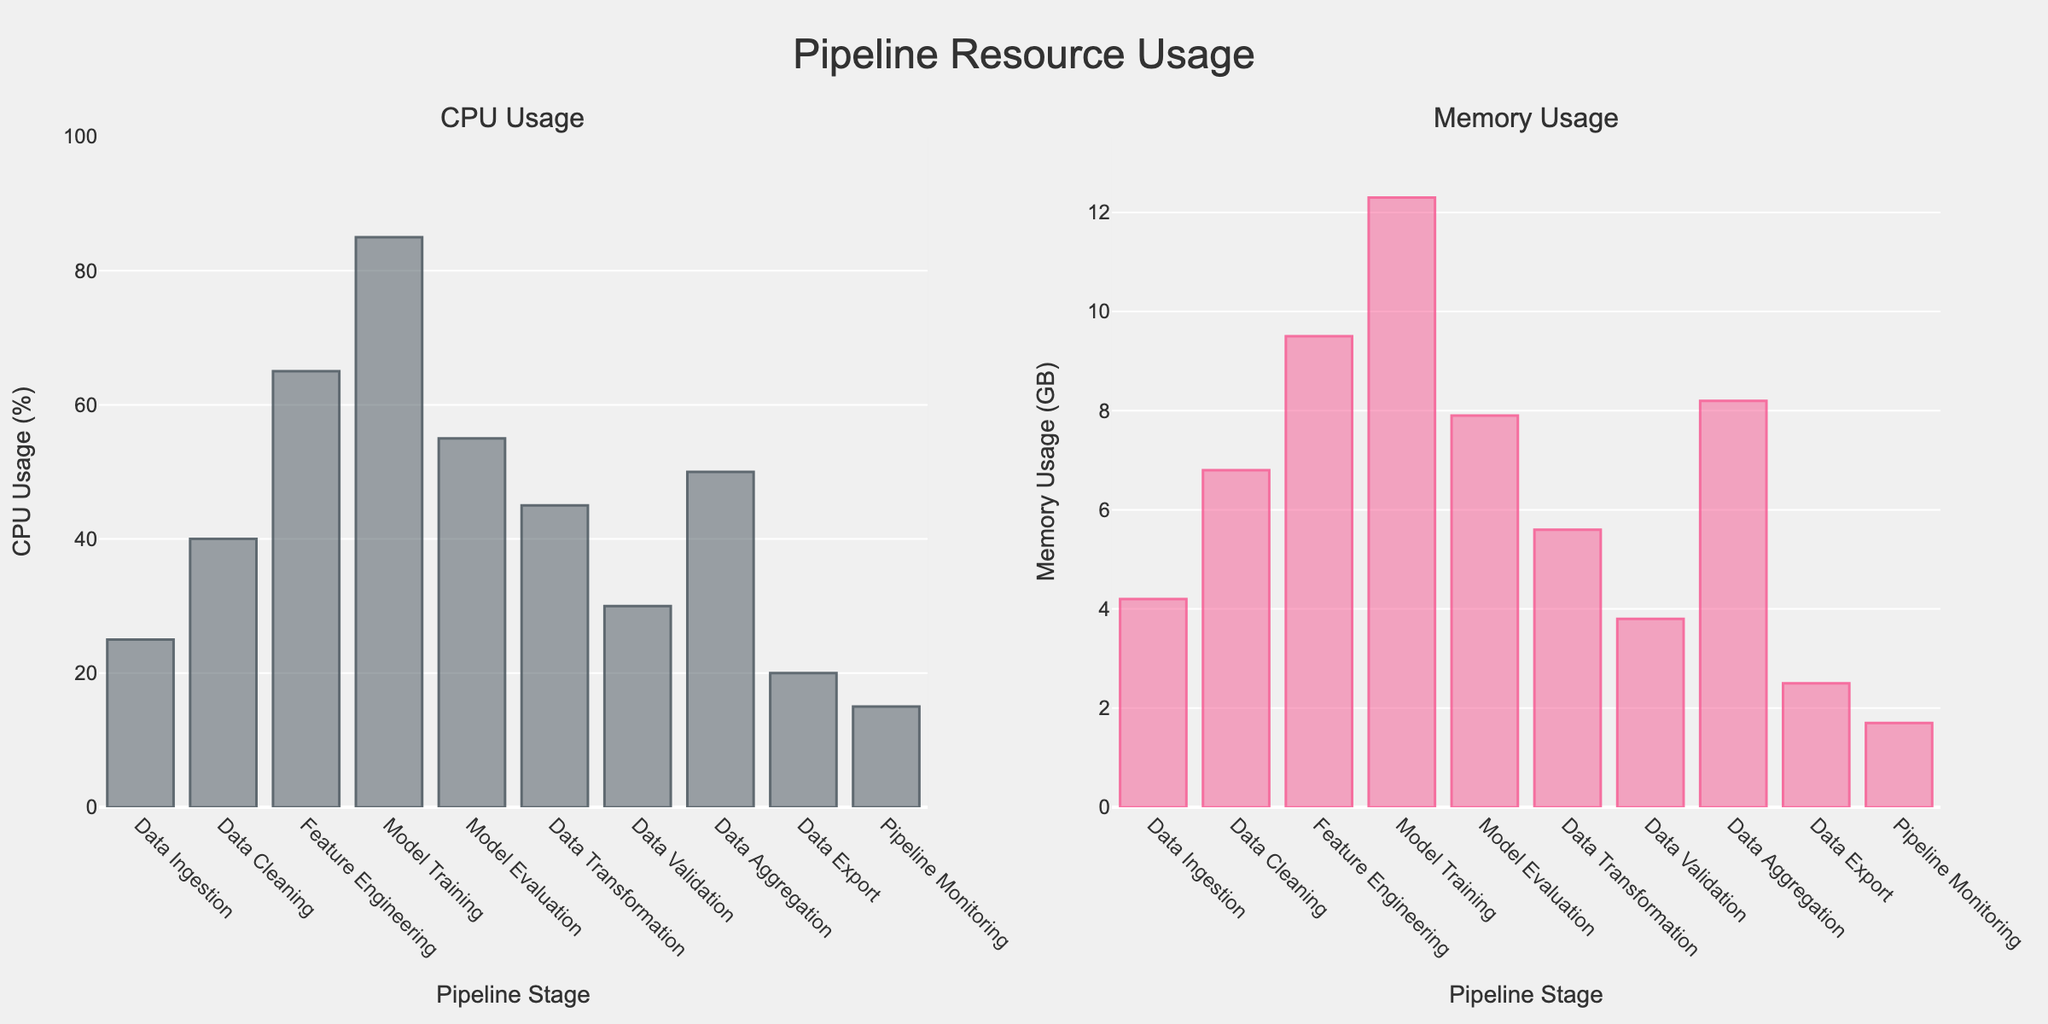What is the title of the figure? The title of the figure is located at the top center of the plot and reads "Pipeline Resource Usage."
Answer: Pipeline Resource Usage What is the CPU usage percentage during Model Training? Locate the bar corresponding to the "Model Training" stage on the left subplot titled "CPU Usage." The height of this bar represents the CPU usage, which is 85%.
Answer: 85% How much memory is used during the Data Aggregation stage? Find the bar labeled "Data Aggregation" in the right subplot titled "Memory Usage." The height of this bar shows the memory usage, which is 8.2 GB.
Answer: 8.2 GB During which stage is the lowest CPU usage observed? Look at the left subplot (CPU Usage) and find the bar with the shortest height. The stage with the shortest bar is "Pipeline Monitoring," indicating the lowest CPU usage.
Answer: Pipeline Monitoring Which stage has the highest memory usage? Check the right subplot (Memory Usage) and identify the bar with the greatest height. The "Model Training" stage has the highest bar, representing the highest memory usage.
Answer: Model Training What is the combined CPU usage percentage for Data Ingestion and Data Export? Identify the CPU usage for "Data Ingestion" (25%) and "Data Export" (20%). Sum these values: 25% + 20% = 45%.
Answer: 45% How does the CPU usage of Data Cleaning compare to Data Validation? Locate the CPU usage for "Data Cleaning" (40%) and "Data Validation" (30%). Data Cleaning has 10% more CPU usage than Data Validation.
Answer: Data Cleaning has 10% more CPU usage than Data Validation What stages have a memory usage greater than 8 GB? Check the right subplot (Memory Usage) and find the bars where the height exceeds 8 GB. These stages are "Feature Engineering" (9.5 GB), "Model Training" (12.3 GB), and "Data Aggregation" (8.2 GB).
Answer: Feature Engineering, Model Training, Data Aggregation Which stages have lower CPU usage than Data Transformation? Locate the CPU usage for "Data Transformation" (45%) and identify the stages with lower values. These are "Data Ingestion" (25%), "Data Validation" (30%), "Data Export" (20%), and "Pipeline Monitoring" (15%).
Answer: Data Ingestion, Data Validation, Data Export, Pipeline Monitoring What is the average memory usage across all stages? Sum all memory usage values: 4.2 + 6.8 + 9.5 + 12.3 + 7.9 + 5.6 + 3.8 + 8.2 + 2.5 + 1.7 = 62.5 GB. Divide by the number of stages (10): 62.5 / 10 = 6.25 GB.
Answer: 6.25 GB 